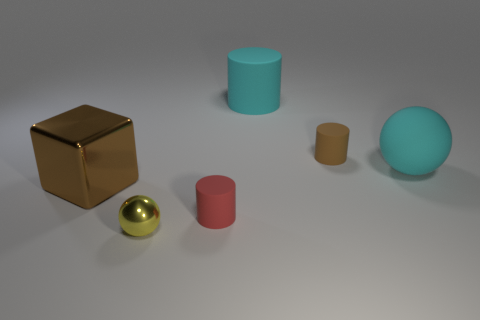Add 1 tiny rubber things. How many objects exist? 7 Subtract all blocks. How many objects are left? 5 Subtract all big brown spheres. Subtract all big cyan matte objects. How many objects are left? 4 Add 2 small red cylinders. How many small red cylinders are left? 3 Add 5 large cyan cylinders. How many large cyan cylinders exist? 6 Subtract 0 red blocks. How many objects are left? 6 